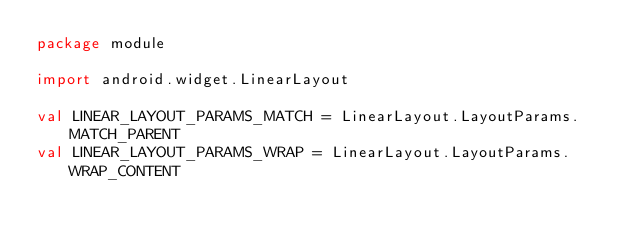<code> <loc_0><loc_0><loc_500><loc_500><_Kotlin_>package module

import android.widget.LinearLayout

val LINEAR_LAYOUT_PARAMS_MATCH = LinearLayout.LayoutParams.MATCH_PARENT
val LINEAR_LAYOUT_PARAMS_WRAP = LinearLayout.LayoutParams.WRAP_CONTENT</code> 